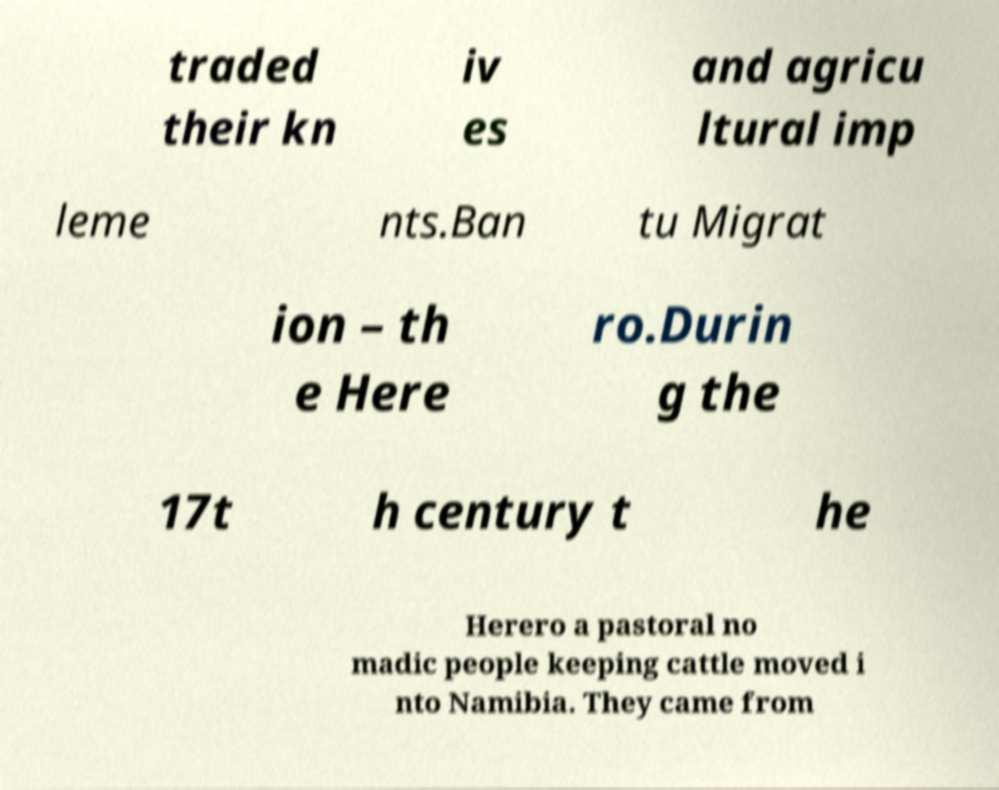What messages or text are displayed in this image? I need them in a readable, typed format. traded their kn iv es and agricu ltural imp leme nts.Ban tu Migrat ion – th e Here ro.Durin g the 17t h century t he Herero a pastoral no madic people keeping cattle moved i nto Namibia. They came from 